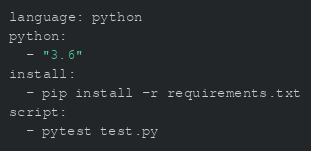Convert code to text. <code><loc_0><loc_0><loc_500><loc_500><_YAML_>language: python
python:
  - "3.6"
install:
  - pip install -r requirements.txt
script:
  - pytest test.py</code> 